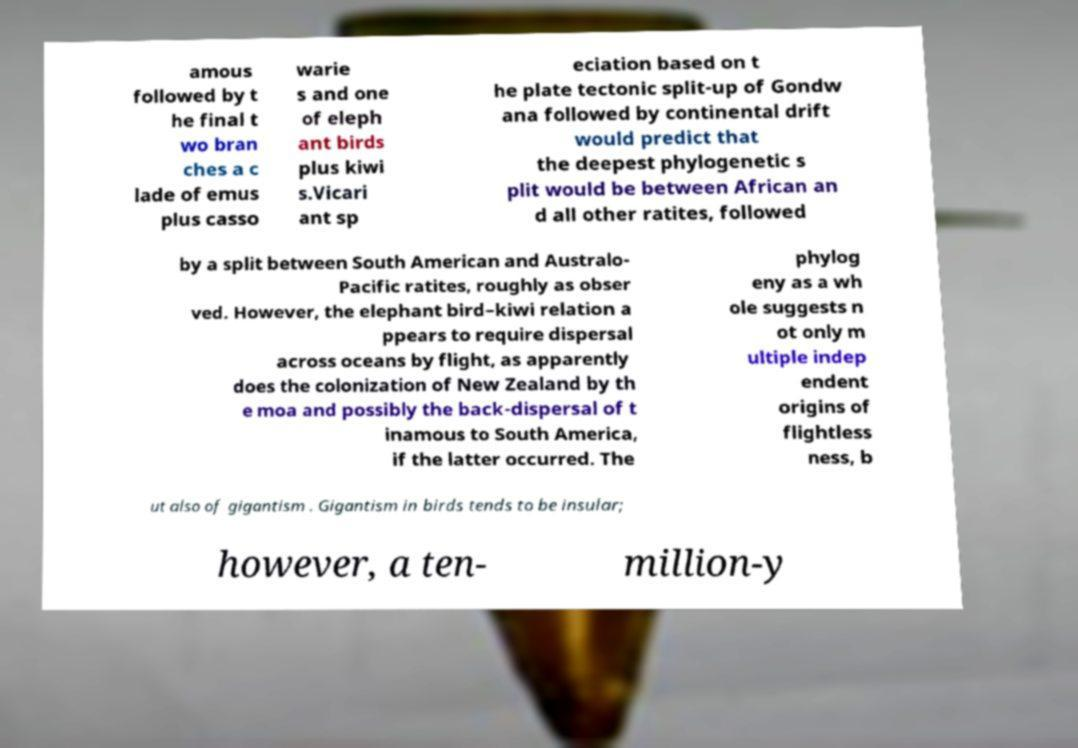Please read and relay the text visible in this image. What does it say? amous followed by t he final t wo bran ches a c lade of emus plus casso warie s and one of eleph ant birds plus kiwi s.Vicari ant sp eciation based on t he plate tectonic split-up of Gondw ana followed by continental drift would predict that the deepest phylogenetic s plit would be between African an d all other ratites, followed by a split between South American and Australo- Pacific ratites, roughly as obser ved. However, the elephant bird–kiwi relation a ppears to require dispersal across oceans by flight, as apparently does the colonization of New Zealand by th e moa and possibly the back-dispersal of t inamous to South America, if the latter occurred. The phylog eny as a wh ole suggests n ot only m ultiple indep endent origins of flightless ness, b ut also of gigantism . Gigantism in birds tends to be insular; however, a ten- million-y 